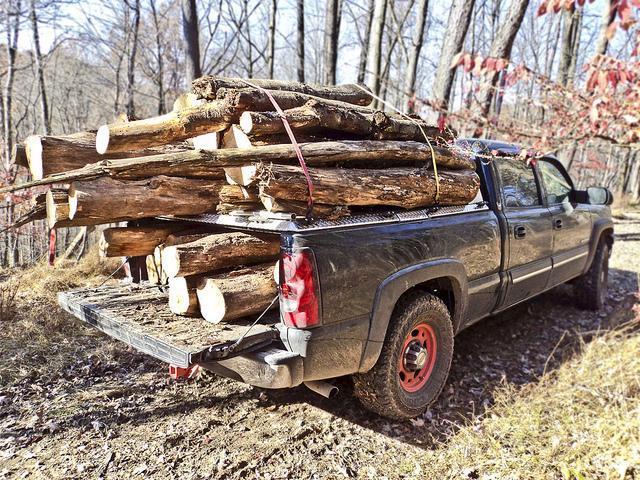How many toothbrushes are here?
Give a very brief answer. 0. 